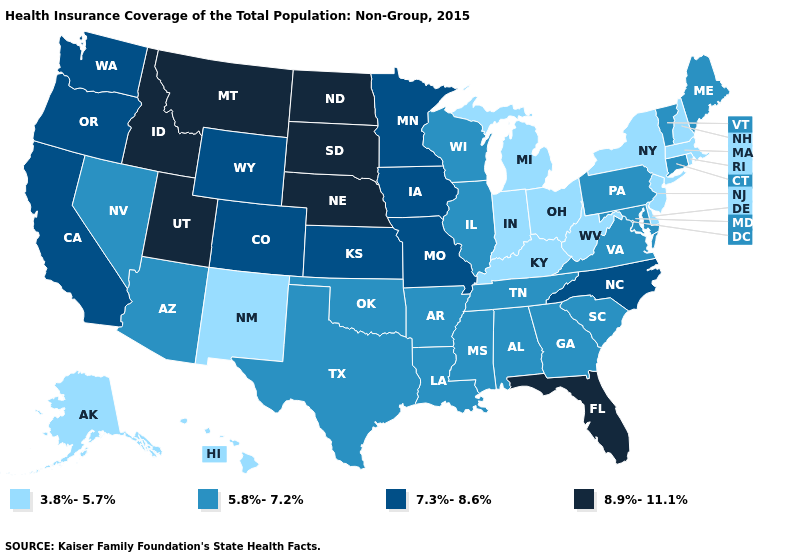What is the value of Tennessee?
Quick response, please. 5.8%-7.2%. What is the lowest value in the Northeast?
Be succinct. 3.8%-5.7%. Does New Jersey have a higher value than Connecticut?
Keep it brief. No. Does the first symbol in the legend represent the smallest category?
Write a very short answer. Yes. Does Indiana have the lowest value in the MidWest?
Answer briefly. Yes. What is the lowest value in the West?
Quick response, please. 3.8%-5.7%. How many symbols are there in the legend?
Answer briefly. 4. Does Utah have the highest value in the West?
Give a very brief answer. Yes. What is the value of Vermont?
Write a very short answer. 5.8%-7.2%. What is the value of Kansas?
Keep it brief. 7.3%-8.6%. What is the highest value in states that border West Virginia?
Be succinct. 5.8%-7.2%. Name the states that have a value in the range 8.9%-11.1%?
Quick response, please. Florida, Idaho, Montana, Nebraska, North Dakota, South Dakota, Utah. Does the first symbol in the legend represent the smallest category?
Concise answer only. Yes. Does the first symbol in the legend represent the smallest category?
Be succinct. Yes. Which states have the lowest value in the West?
Concise answer only. Alaska, Hawaii, New Mexico. 